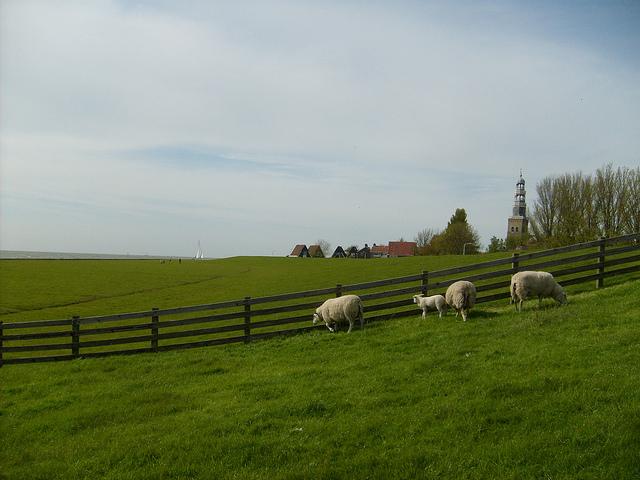Which one is not with the group?
Keep it brief. One on left. How many black sheep?
Be succinct. 0. Is there a fence in the picture?
Be succinct. Yes. How many sheep are there?
Concise answer only. 4. Is there any fence in the picture?
Write a very short answer. Yes. What is standing directly behind the sheep?
Answer briefly. Fence. 